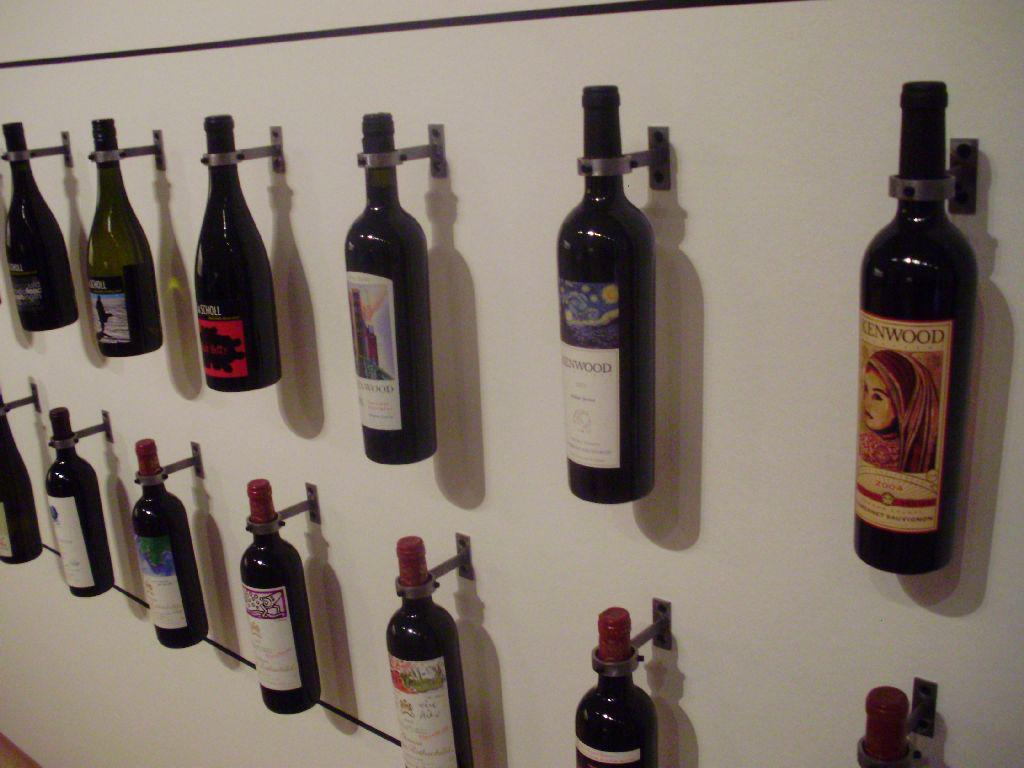What type of bottles are hanging on the board in the image? There are wine bottles in the image. How are the wine bottles arranged in the image? The wine bottles are hanging on a board. What type of fiction is being exchanged between the wine bottles in the image? There is no fiction or exchange happening between the wine bottles in the image; they are simply hanging on a board. 